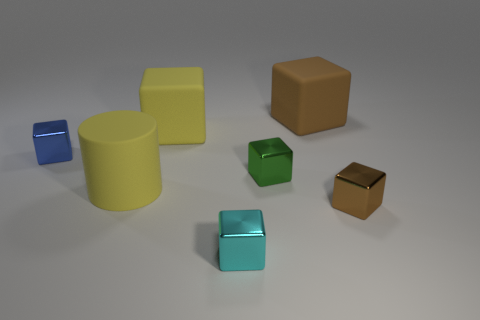What number of other objects are the same shape as the tiny brown metallic object?
Your answer should be compact. 5. Are there any large matte cubes right of the yellow matte block?
Provide a short and direct response. Yes. The large matte cylinder has what color?
Your answer should be very brief. Yellow. There is a cylinder; does it have the same color as the thing on the left side of the large yellow rubber cylinder?
Provide a short and direct response. No. Is there a green shiny ball that has the same size as the brown rubber cube?
Give a very brief answer. No. The rubber cube that is the same color as the big rubber cylinder is what size?
Give a very brief answer. Large. There is a brown thing that is in front of the large matte cylinder; what material is it?
Give a very brief answer. Metal. Are there the same number of small blocks that are to the right of the green thing and tiny green metallic things behind the big cylinder?
Keep it short and to the point. Yes. Do the rubber block to the left of the cyan cube and the metal thing right of the brown matte cube have the same size?
Offer a terse response. No. What number of tiny metal objects are the same color as the rubber cylinder?
Ensure brevity in your answer.  0. 